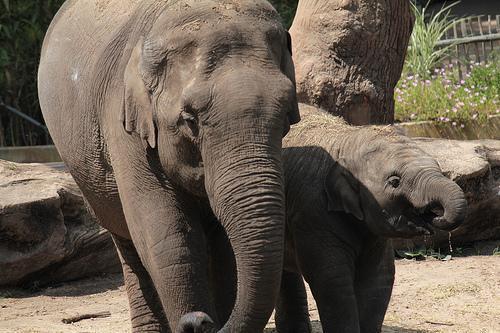How many elephants in the zoo?
Give a very brief answer. 2. 